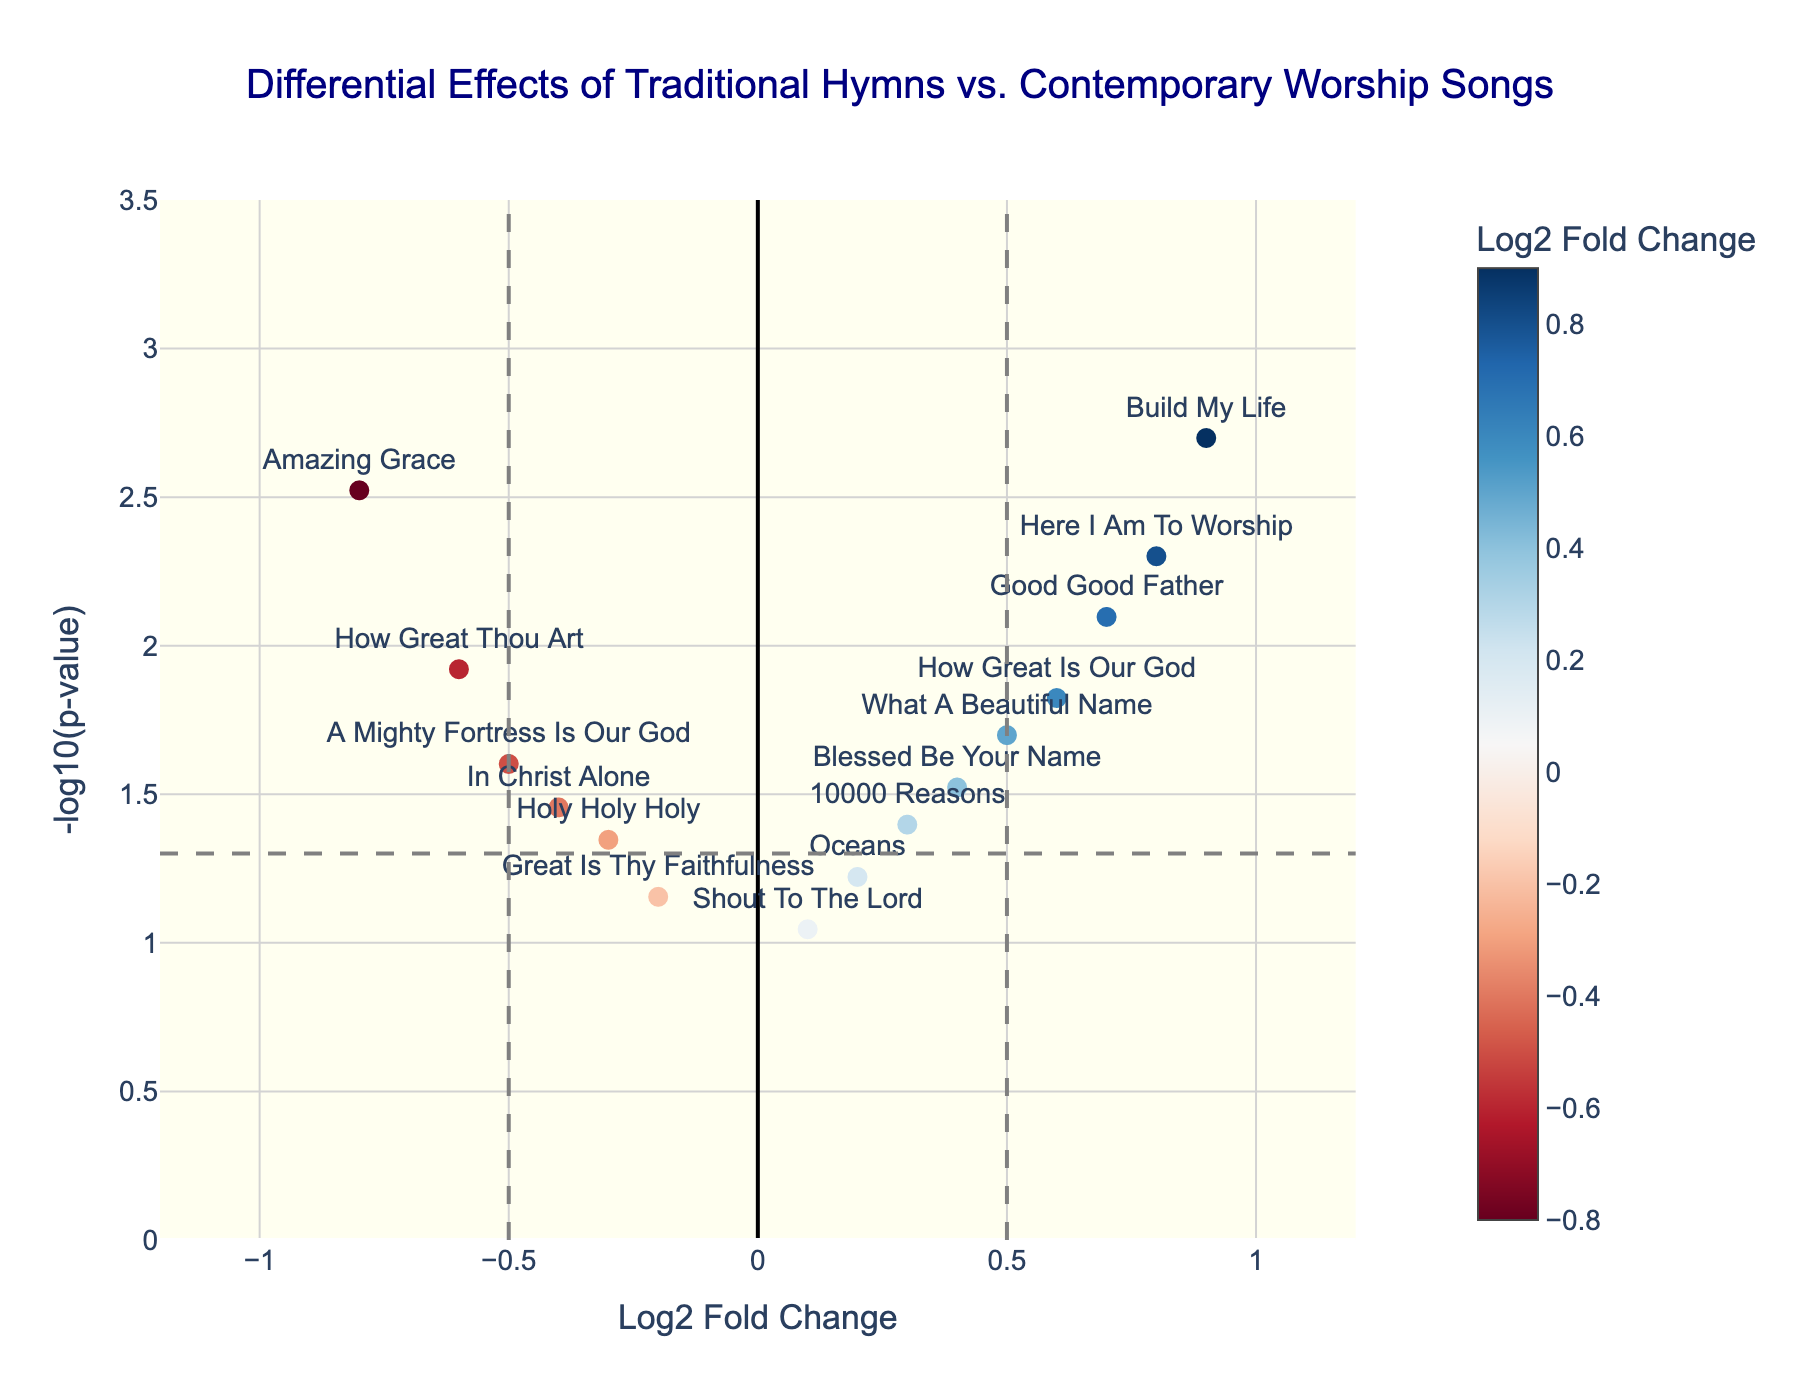What is the title of the plot? The title is displayed at the top of the plot, which reads "Differential Effects of Traditional Hymns vs. Contemporary Worship Songs."
Answer: Differential Effects of Traditional Hymns vs. Contemporary Worship Songs What is represented by the x-axis in the plot? The x-axis is labeled "Log2 Fold Change," indicating it represents the Log2 Fold Change of the songs.
Answer: Log2 Fold Change How many songs have a Log2 Fold Change greater than 0.5? From the plot, there are three songs with Log2 Fold Change greater than 0.5: "Build My Life," "Here I Am To Worship," and "Good Good Father."
Answer: Three What color scale is used for the markers in the plot? The color scale used for the markers ranges from blue to red, with blue representing negative fold changes and red representing positive fold changes, as shown in the color bar included with the plot.
Answer: Blue to red Which song has the highest -log10(p-value)? By observing the y-axis, the song with the highest -log10(p-value) is "Build My Life," indicated by its position at the top of the plot.
Answer: Build My Life What is the p-value threshold indicated by the horizontal dashed line? The horizontal dashed line represents a p-value of 0.05. For p-values, -log10(0.05) approximately equals 1.30, marking the threshold.
Answer: 0.05 Which song has the most positive Log2 Fold Change? The song "Build My Life" has the most positive Log2 Fold Change, as it is located farthest to the right on the x-axis with a value of 0.9.
Answer: Build My Life How many songs fall within the critical region with Log2 Fold Change less than -0.5 and p-value less than 0.05? To fall within the critical region, songs must be located to the left of the vertical dashed line at -0.5 and above the horizontal dashed line at -log10(0.05). Only "Amazing Grace" meets these criteria.
Answer: One Compare the Log2 Fold Change of "Great Is Thy Faithfulness" and "Blessed Be Your Name." Which song has a greater fold change? To compare, we find "Great Is Thy Faithfulness" has a Log2 Fold Change of -0.2, and "Blessed Be Your Name" has a Log2 Fold Change of 0.4. "Blessed Be Your Name" has the greater fold change.
Answer: Blessed Be Your Name What does the vertical dashed line at x = -0.5 indicate in this volcano plot? The vertical dashed line at x = -0.5 indicates the boundary for significant negative Log2 Fold Change values in this analysis. Points left of this line demonstrate notably reduced engagement levels.
Answer: Boundary for significant negative changes 